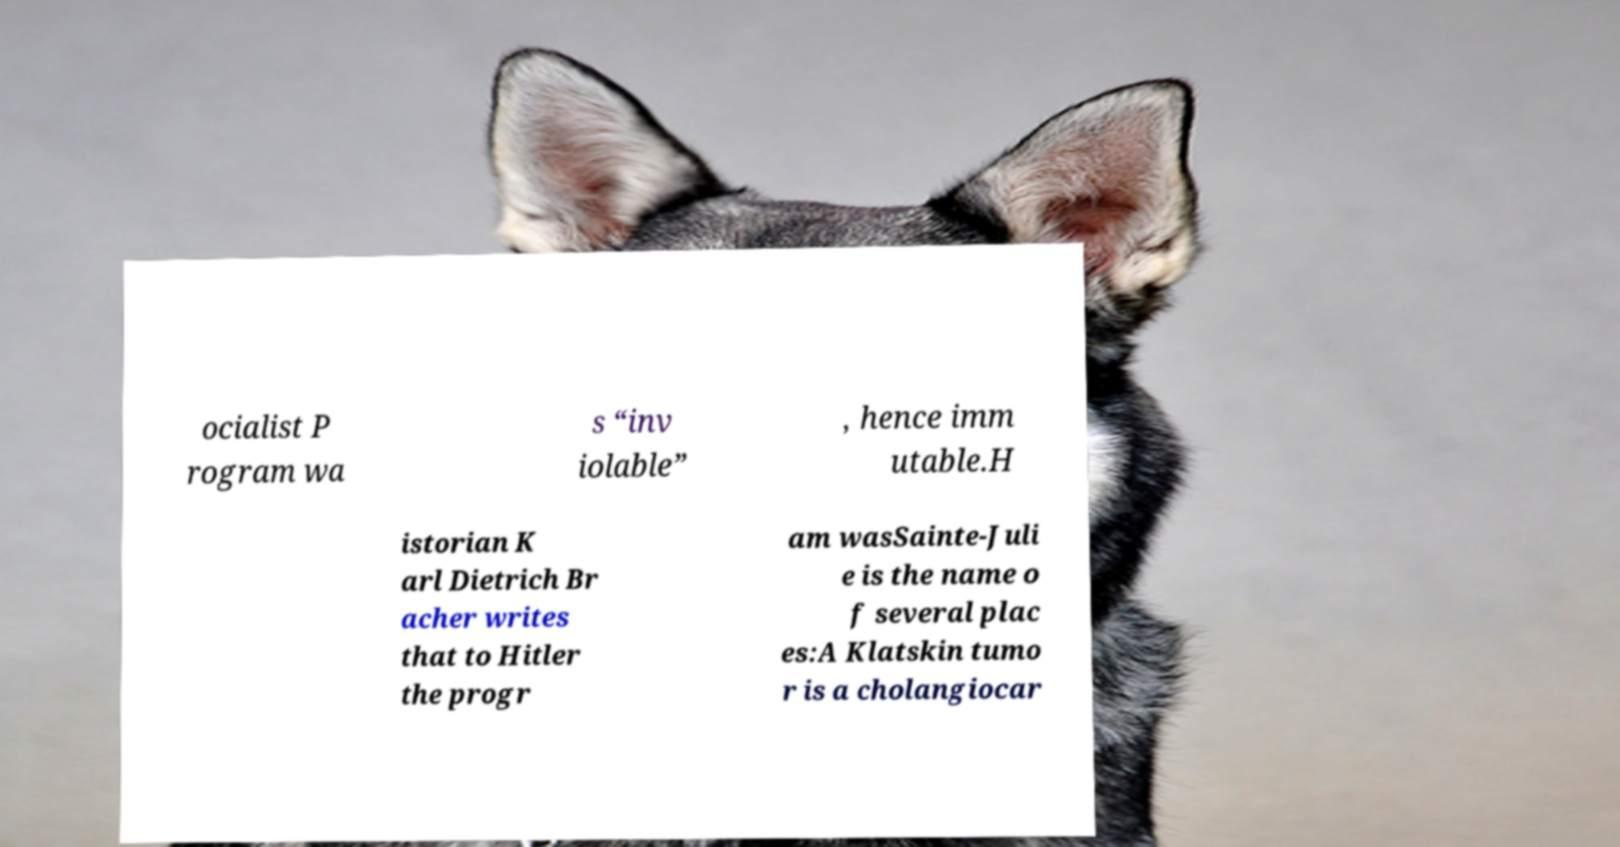There's text embedded in this image that I need extracted. Can you transcribe it verbatim? ocialist P rogram wa s “inv iolable” , hence imm utable.H istorian K arl Dietrich Br acher writes that to Hitler the progr am wasSainte-Juli e is the name o f several plac es:A Klatskin tumo r is a cholangiocar 